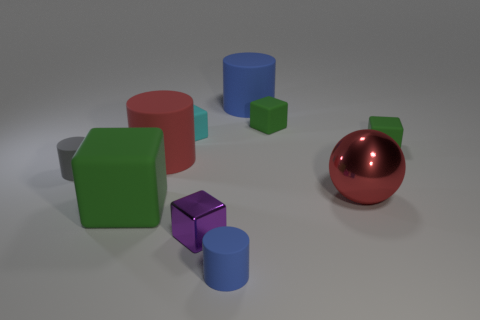How many green blocks must be subtracted to get 1 green blocks? 2 Subtract all brown balls. How many green blocks are left? 3 Subtract all cyan blocks. How many blocks are left? 4 Subtract all small purple cubes. How many cubes are left? 4 Subtract all yellow blocks. Subtract all purple cylinders. How many blocks are left? 5 Subtract all cylinders. How many objects are left? 6 Subtract 0 gray blocks. How many objects are left? 10 Subtract all large gray rubber cubes. Subtract all metallic balls. How many objects are left? 9 Add 9 red metal balls. How many red metal balls are left? 10 Add 1 small gray objects. How many small gray objects exist? 2 